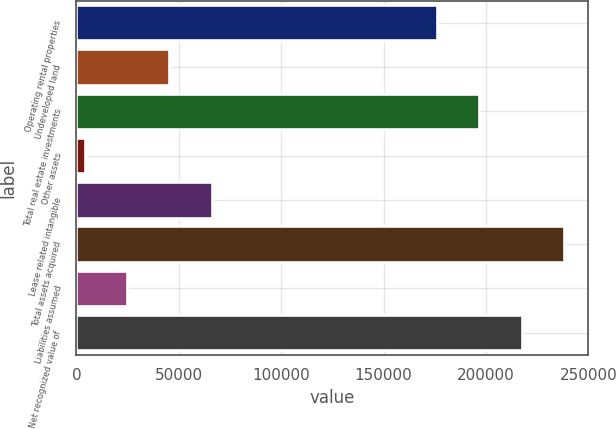Convert chart to OTSL. <chart><loc_0><loc_0><loc_500><loc_500><bar_chart><fcel>Operating rental properties<fcel>Undeveloped land<fcel>Total real estate investments<fcel>Other assets<fcel>Lease related intangible<fcel>Total assets acquired<fcel>Liabilities assumed<fcel>Net recognized value of<nl><fcel>176038<fcel>45364.6<fcel>196727<fcel>3987<fcel>66053.4<fcel>238104<fcel>24675.8<fcel>217416<nl></chart> 